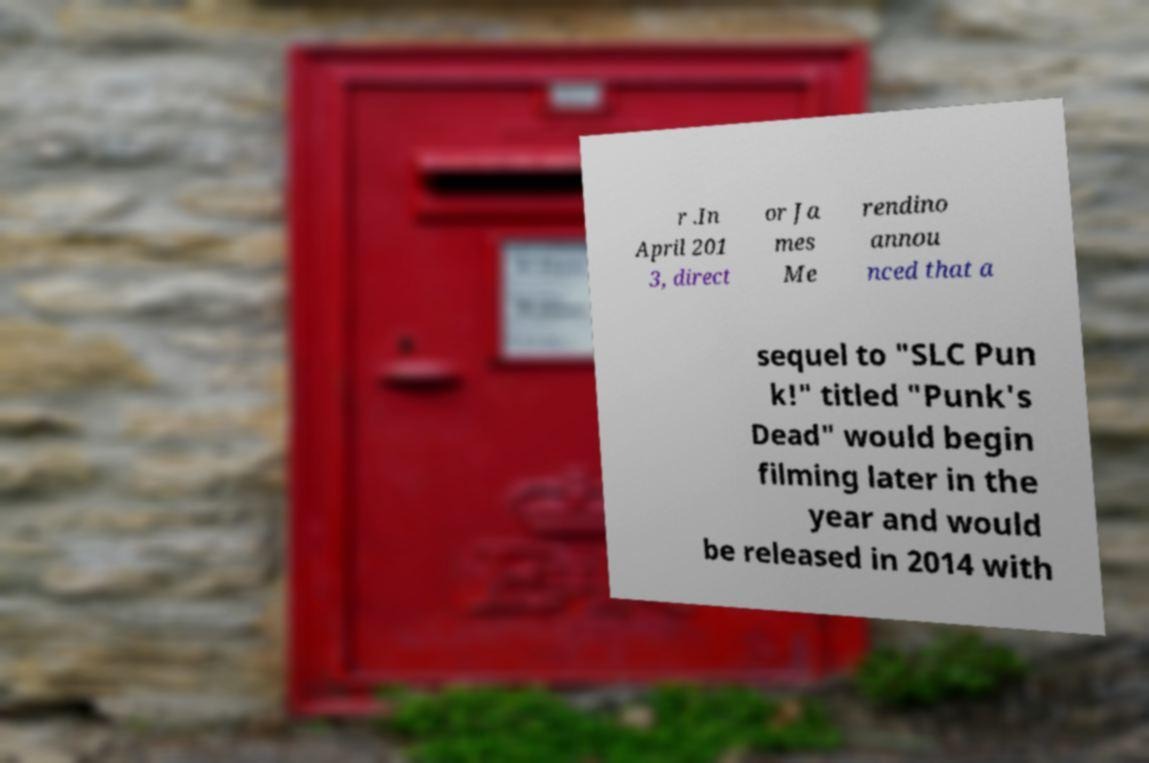What messages or text are displayed in this image? I need them in a readable, typed format. r .In April 201 3, direct or Ja mes Me rendino annou nced that a sequel to "SLC Pun k!" titled "Punk's Dead" would begin filming later in the year and would be released in 2014 with 